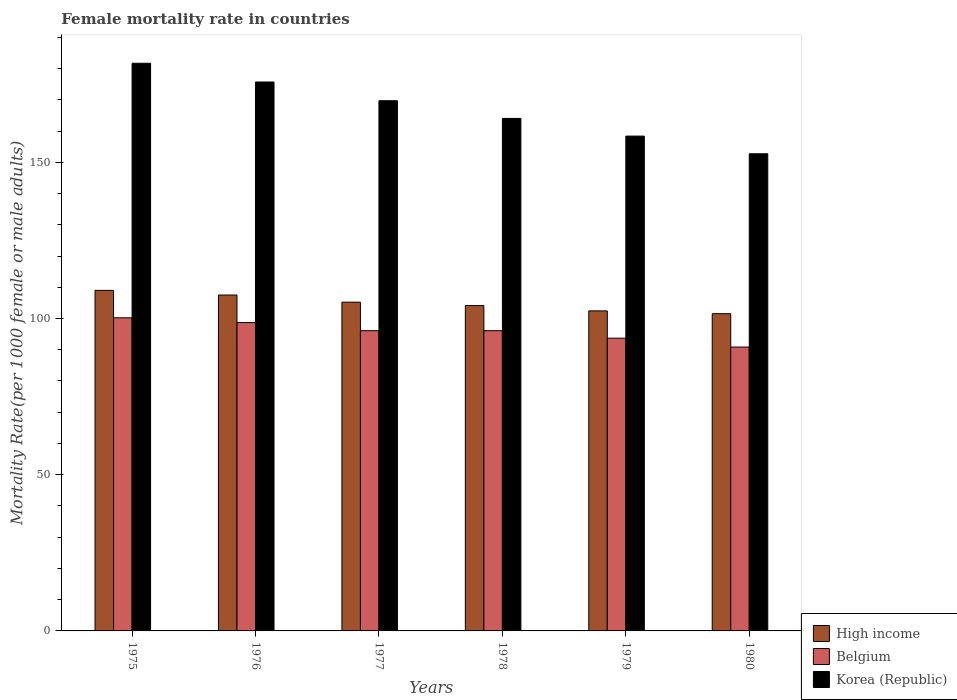Are the number of bars on each tick of the X-axis equal?
Your response must be concise. Yes. What is the label of the 4th group of bars from the left?
Make the answer very short. 1978. In how many cases, is the number of bars for a given year not equal to the number of legend labels?
Provide a succinct answer. 0. What is the female mortality rate in High income in 1977?
Your answer should be very brief. 105.23. Across all years, what is the maximum female mortality rate in Korea (Republic)?
Make the answer very short. 181.69. Across all years, what is the minimum female mortality rate in Korea (Republic)?
Ensure brevity in your answer.  152.72. In which year was the female mortality rate in Belgium maximum?
Provide a short and direct response. 1975. In which year was the female mortality rate in High income minimum?
Offer a very short reply. 1980. What is the total female mortality rate in High income in the graph?
Provide a succinct answer. 629.84. What is the difference between the female mortality rate in Belgium in 1976 and that in 1979?
Provide a short and direct response. 4.98. What is the difference between the female mortality rate in High income in 1976 and the female mortality rate in Belgium in 1979?
Your answer should be very brief. 13.81. What is the average female mortality rate in Korea (Republic) per year?
Make the answer very short. 167.04. In the year 1980, what is the difference between the female mortality rate in High income and female mortality rate in Korea (Republic)?
Ensure brevity in your answer.  -51.18. In how many years, is the female mortality rate in Belgium greater than 150?
Provide a succinct answer. 0. What is the ratio of the female mortality rate in Belgium in 1979 to that in 1980?
Your answer should be very brief. 1.03. Is the difference between the female mortality rate in High income in 1978 and 1980 greater than the difference between the female mortality rate in Korea (Republic) in 1978 and 1980?
Your answer should be compact. No. What is the difference between the highest and the second highest female mortality rate in Korea (Republic)?
Give a very brief answer. 6. What is the difference between the highest and the lowest female mortality rate in Korea (Republic)?
Your answer should be very brief. 28.97. In how many years, is the female mortality rate in High income greater than the average female mortality rate in High income taken over all years?
Your answer should be very brief. 3. Is the sum of the female mortality rate in Belgium in 1975 and 1977 greater than the maximum female mortality rate in Korea (Republic) across all years?
Provide a short and direct response. Yes. What does the 3rd bar from the left in 1978 represents?
Keep it short and to the point. Korea (Republic). Are all the bars in the graph horizontal?
Give a very brief answer. No. Are the values on the major ticks of Y-axis written in scientific E-notation?
Your answer should be very brief. No. How many legend labels are there?
Provide a short and direct response. 3. How are the legend labels stacked?
Offer a very short reply. Vertical. What is the title of the graph?
Offer a very short reply. Female mortality rate in countries. What is the label or title of the X-axis?
Offer a terse response. Years. What is the label or title of the Y-axis?
Provide a succinct answer. Mortality Rate(per 1000 female or male adults). What is the Mortality Rate(per 1000 female or male adults) in High income in 1975?
Provide a succinct answer. 109. What is the Mortality Rate(per 1000 female or male adults) in Belgium in 1975?
Your answer should be compact. 100.22. What is the Mortality Rate(per 1000 female or male adults) in Korea (Republic) in 1975?
Your response must be concise. 181.69. What is the Mortality Rate(per 1000 female or male adults) of High income in 1976?
Offer a very short reply. 107.51. What is the Mortality Rate(per 1000 female or male adults) in Belgium in 1976?
Your answer should be compact. 98.69. What is the Mortality Rate(per 1000 female or male adults) of Korea (Republic) in 1976?
Offer a very short reply. 175.7. What is the Mortality Rate(per 1000 female or male adults) of High income in 1977?
Offer a very short reply. 105.23. What is the Mortality Rate(per 1000 female or male adults) in Belgium in 1977?
Ensure brevity in your answer.  96.09. What is the Mortality Rate(per 1000 female or male adults) of Korea (Republic) in 1977?
Your answer should be compact. 169.7. What is the Mortality Rate(per 1000 female or male adults) in High income in 1978?
Provide a succinct answer. 104.13. What is the Mortality Rate(per 1000 female or male adults) in Belgium in 1978?
Ensure brevity in your answer.  96.09. What is the Mortality Rate(per 1000 female or male adults) of Korea (Republic) in 1978?
Give a very brief answer. 164.04. What is the Mortality Rate(per 1000 female or male adults) in High income in 1979?
Offer a very short reply. 102.43. What is the Mortality Rate(per 1000 female or male adults) in Belgium in 1979?
Provide a short and direct response. 93.7. What is the Mortality Rate(per 1000 female or male adults) in Korea (Republic) in 1979?
Offer a very short reply. 158.38. What is the Mortality Rate(per 1000 female or male adults) of High income in 1980?
Make the answer very short. 101.54. What is the Mortality Rate(per 1000 female or male adults) of Belgium in 1980?
Ensure brevity in your answer.  90.86. What is the Mortality Rate(per 1000 female or male adults) in Korea (Republic) in 1980?
Your answer should be compact. 152.72. Across all years, what is the maximum Mortality Rate(per 1000 female or male adults) of High income?
Offer a terse response. 109. Across all years, what is the maximum Mortality Rate(per 1000 female or male adults) of Belgium?
Give a very brief answer. 100.22. Across all years, what is the maximum Mortality Rate(per 1000 female or male adults) of Korea (Republic)?
Ensure brevity in your answer.  181.69. Across all years, what is the minimum Mortality Rate(per 1000 female or male adults) of High income?
Offer a terse response. 101.54. Across all years, what is the minimum Mortality Rate(per 1000 female or male adults) in Belgium?
Offer a very short reply. 90.86. Across all years, what is the minimum Mortality Rate(per 1000 female or male adults) in Korea (Republic)?
Give a very brief answer. 152.72. What is the total Mortality Rate(per 1000 female or male adults) of High income in the graph?
Offer a terse response. 629.84. What is the total Mortality Rate(per 1000 female or male adults) in Belgium in the graph?
Give a very brief answer. 575.66. What is the total Mortality Rate(per 1000 female or male adults) of Korea (Republic) in the graph?
Offer a very short reply. 1002.23. What is the difference between the Mortality Rate(per 1000 female or male adults) of High income in 1975 and that in 1976?
Your answer should be compact. 1.49. What is the difference between the Mortality Rate(per 1000 female or male adults) in Belgium in 1975 and that in 1976?
Your answer should be compact. 1.53. What is the difference between the Mortality Rate(per 1000 female or male adults) of Korea (Republic) in 1975 and that in 1976?
Give a very brief answer. 6. What is the difference between the Mortality Rate(per 1000 female or male adults) in High income in 1975 and that in 1977?
Provide a short and direct response. 3.77. What is the difference between the Mortality Rate(per 1000 female or male adults) in Belgium in 1975 and that in 1977?
Provide a succinct answer. 4.13. What is the difference between the Mortality Rate(per 1000 female or male adults) in Korea (Republic) in 1975 and that in 1977?
Your response must be concise. 11.99. What is the difference between the Mortality Rate(per 1000 female or male adults) in High income in 1975 and that in 1978?
Your answer should be compact. 4.87. What is the difference between the Mortality Rate(per 1000 female or male adults) in Belgium in 1975 and that in 1978?
Offer a terse response. 4.13. What is the difference between the Mortality Rate(per 1000 female or male adults) of Korea (Republic) in 1975 and that in 1978?
Keep it short and to the point. 17.65. What is the difference between the Mortality Rate(per 1000 female or male adults) of High income in 1975 and that in 1979?
Give a very brief answer. 6.56. What is the difference between the Mortality Rate(per 1000 female or male adults) in Belgium in 1975 and that in 1979?
Ensure brevity in your answer.  6.52. What is the difference between the Mortality Rate(per 1000 female or male adults) in Korea (Republic) in 1975 and that in 1979?
Keep it short and to the point. 23.31. What is the difference between the Mortality Rate(per 1000 female or male adults) of High income in 1975 and that in 1980?
Give a very brief answer. 7.46. What is the difference between the Mortality Rate(per 1000 female or male adults) in Belgium in 1975 and that in 1980?
Ensure brevity in your answer.  9.36. What is the difference between the Mortality Rate(per 1000 female or male adults) in Korea (Republic) in 1975 and that in 1980?
Offer a terse response. 28.97. What is the difference between the Mortality Rate(per 1000 female or male adults) of High income in 1976 and that in 1977?
Keep it short and to the point. 2.28. What is the difference between the Mortality Rate(per 1000 female or male adults) of Belgium in 1976 and that in 1977?
Provide a short and direct response. 2.6. What is the difference between the Mortality Rate(per 1000 female or male adults) of Korea (Republic) in 1976 and that in 1977?
Offer a very short reply. 6. What is the difference between the Mortality Rate(per 1000 female or male adults) in High income in 1976 and that in 1978?
Provide a short and direct response. 3.38. What is the difference between the Mortality Rate(per 1000 female or male adults) in Belgium in 1976 and that in 1978?
Provide a short and direct response. 2.59. What is the difference between the Mortality Rate(per 1000 female or male adults) in Korea (Republic) in 1976 and that in 1978?
Keep it short and to the point. 11.66. What is the difference between the Mortality Rate(per 1000 female or male adults) in High income in 1976 and that in 1979?
Give a very brief answer. 5.08. What is the difference between the Mortality Rate(per 1000 female or male adults) of Belgium in 1976 and that in 1979?
Ensure brevity in your answer.  4.98. What is the difference between the Mortality Rate(per 1000 female or male adults) in Korea (Republic) in 1976 and that in 1979?
Your answer should be compact. 17.32. What is the difference between the Mortality Rate(per 1000 female or male adults) of High income in 1976 and that in 1980?
Your answer should be very brief. 5.97. What is the difference between the Mortality Rate(per 1000 female or male adults) of Belgium in 1976 and that in 1980?
Provide a succinct answer. 7.83. What is the difference between the Mortality Rate(per 1000 female or male adults) of Korea (Republic) in 1976 and that in 1980?
Provide a short and direct response. 22.98. What is the difference between the Mortality Rate(per 1000 female or male adults) of High income in 1977 and that in 1978?
Give a very brief answer. 1.1. What is the difference between the Mortality Rate(per 1000 female or male adults) of Belgium in 1977 and that in 1978?
Your answer should be compact. -0. What is the difference between the Mortality Rate(per 1000 female or male adults) in Korea (Republic) in 1977 and that in 1978?
Keep it short and to the point. 5.66. What is the difference between the Mortality Rate(per 1000 female or male adults) of High income in 1977 and that in 1979?
Your response must be concise. 2.79. What is the difference between the Mortality Rate(per 1000 female or male adults) of Belgium in 1977 and that in 1979?
Give a very brief answer. 2.39. What is the difference between the Mortality Rate(per 1000 female or male adults) in Korea (Republic) in 1977 and that in 1979?
Provide a succinct answer. 11.32. What is the difference between the Mortality Rate(per 1000 female or male adults) of High income in 1977 and that in 1980?
Provide a succinct answer. 3.69. What is the difference between the Mortality Rate(per 1000 female or male adults) of Belgium in 1977 and that in 1980?
Your answer should be compact. 5.23. What is the difference between the Mortality Rate(per 1000 female or male adults) of Korea (Republic) in 1977 and that in 1980?
Provide a succinct answer. 16.98. What is the difference between the Mortality Rate(per 1000 female or male adults) in High income in 1978 and that in 1979?
Ensure brevity in your answer.  1.7. What is the difference between the Mortality Rate(per 1000 female or male adults) of Belgium in 1978 and that in 1979?
Keep it short and to the point. 2.39. What is the difference between the Mortality Rate(per 1000 female or male adults) of Korea (Republic) in 1978 and that in 1979?
Your answer should be very brief. 5.66. What is the difference between the Mortality Rate(per 1000 female or male adults) of High income in 1978 and that in 1980?
Make the answer very short. 2.59. What is the difference between the Mortality Rate(per 1000 female or male adults) of Belgium in 1978 and that in 1980?
Your answer should be very brief. 5.24. What is the difference between the Mortality Rate(per 1000 female or male adults) in Korea (Republic) in 1978 and that in 1980?
Ensure brevity in your answer.  11.32. What is the difference between the Mortality Rate(per 1000 female or male adults) of High income in 1979 and that in 1980?
Provide a succinct answer. 0.89. What is the difference between the Mortality Rate(per 1000 female or male adults) of Belgium in 1979 and that in 1980?
Offer a very short reply. 2.85. What is the difference between the Mortality Rate(per 1000 female or male adults) in Korea (Republic) in 1979 and that in 1980?
Keep it short and to the point. 5.66. What is the difference between the Mortality Rate(per 1000 female or male adults) in High income in 1975 and the Mortality Rate(per 1000 female or male adults) in Belgium in 1976?
Provide a short and direct response. 10.31. What is the difference between the Mortality Rate(per 1000 female or male adults) in High income in 1975 and the Mortality Rate(per 1000 female or male adults) in Korea (Republic) in 1976?
Make the answer very short. -66.7. What is the difference between the Mortality Rate(per 1000 female or male adults) in Belgium in 1975 and the Mortality Rate(per 1000 female or male adults) in Korea (Republic) in 1976?
Give a very brief answer. -75.48. What is the difference between the Mortality Rate(per 1000 female or male adults) of High income in 1975 and the Mortality Rate(per 1000 female or male adults) of Belgium in 1977?
Keep it short and to the point. 12.9. What is the difference between the Mortality Rate(per 1000 female or male adults) in High income in 1975 and the Mortality Rate(per 1000 female or male adults) in Korea (Republic) in 1977?
Your answer should be very brief. -60.7. What is the difference between the Mortality Rate(per 1000 female or male adults) of Belgium in 1975 and the Mortality Rate(per 1000 female or male adults) of Korea (Republic) in 1977?
Provide a short and direct response. -69.48. What is the difference between the Mortality Rate(per 1000 female or male adults) of High income in 1975 and the Mortality Rate(per 1000 female or male adults) of Belgium in 1978?
Keep it short and to the point. 12.9. What is the difference between the Mortality Rate(per 1000 female or male adults) in High income in 1975 and the Mortality Rate(per 1000 female or male adults) in Korea (Republic) in 1978?
Keep it short and to the point. -55.04. What is the difference between the Mortality Rate(per 1000 female or male adults) of Belgium in 1975 and the Mortality Rate(per 1000 female or male adults) of Korea (Republic) in 1978?
Your answer should be compact. -63.82. What is the difference between the Mortality Rate(per 1000 female or male adults) in High income in 1975 and the Mortality Rate(per 1000 female or male adults) in Belgium in 1979?
Make the answer very short. 15.29. What is the difference between the Mortality Rate(per 1000 female or male adults) of High income in 1975 and the Mortality Rate(per 1000 female or male adults) of Korea (Republic) in 1979?
Offer a very short reply. -49.38. What is the difference between the Mortality Rate(per 1000 female or male adults) in Belgium in 1975 and the Mortality Rate(per 1000 female or male adults) in Korea (Republic) in 1979?
Your answer should be very brief. -58.16. What is the difference between the Mortality Rate(per 1000 female or male adults) in High income in 1975 and the Mortality Rate(per 1000 female or male adults) in Belgium in 1980?
Your response must be concise. 18.14. What is the difference between the Mortality Rate(per 1000 female or male adults) of High income in 1975 and the Mortality Rate(per 1000 female or male adults) of Korea (Republic) in 1980?
Make the answer very short. -43.72. What is the difference between the Mortality Rate(per 1000 female or male adults) in Belgium in 1975 and the Mortality Rate(per 1000 female or male adults) in Korea (Republic) in 1980?
Make the answer very short. -52.5. What is the difference between the Mortality Rate(per 1000 female or male adults) in High income in 1976 and the Mortality Rate(per 1000 female or male adults) in Belgium in 1977?
Give a very brief answer. 11.42. What is the difference between the Mortality Rate(per 1000 female or male adults) in High income in 1976 and the Mortality Rate(per 1000 female or male adults) in Korea (Republic) in 1977?
Your answer should be very brief. -62.19. What is the difference between the Mortality Rate(per 1000 female or male adults) of Belgium in 1976 and the Mortality Rate(per 1000 female or male adults) of Korea (Republic) in 1977?
Offer a terse response. -71.01. What is the difference between the Mortality Rate(per 1000 female or male adults) of High income in 1976 and the Mortality Rate(per 1000 female or male adults) of Belgium in 1978?
Provide a succinct answer. 11.42. What is the difference between the Mortality Rate(per 1000 female or male adults) in High income in 1976 and the Mortality Rate(per 1000 female or male adults) in Korea (Republic) in 1978?
Your response must be concise. -56.53. What is the difference between the Mortality Rate(per 1000 female or male adults) of Belgium in 1976 and the Mortality Rate(per 1000 female or male adults) of Korea (Republic) in 1978?
Your answer should be compact. -65.35. What is the difference between the Mortality Rate(per 1000 female or male adults) of High income in 1976 and the Mortality Rate(per 1000 female or male adults) of Belgium in 1979?
Ensure brevity in your answer.  13.81. What is the difference between the Mortality Rate(per 1000 female or male adults) of High income in 1976 and the Mortality Rate(per 1000 female or male adults) of Korea (Republic) in 1979?
Provide a succinct answer. -50.87. What is the difference between the Mortality Rate(per 1000 female or male adults) of Belgium in 1976 and the Mortality Rate(per 1000 female or male adults) of Korea (Republic) in 1979?
Keep it short and to the point. -59.69. What is the difference between the Mortality Rate(per 1000 female or male adults) of High income in 1976 and the Mortality Rate(per 1000 female or male adults) of Belgium in 1980?
Provide a succinct answer. 16.65. What is the difference between the Mortality Rate(per 1000 female or male adults) of High income in 1976 and the Mortality Rate(per 1000 female or male adults) of Korea (Republic) in 1980?
Offer a very short reply. -45.21. What is the difference between the Mortality Rate(per 1000 female or male adults) in Belgium in 1976 and the Mortality Rate(per 1000 female or male adults) in Korea (Republic) in 1980?
Offer a very short reply. -54.03. What is the difference between the Mortality Rate(per 1000 female or male adults) of High income in 1977 and the Mortality Rate(per 1000 female or male adults) of Belgium in 1978?
Make the answer very short. 9.13. What is the difference between the Mortality Rate(per 1000 female or male adults) of High income in 1977 and the Mortality Rate(per 1000 female or male adults) of Korea (Republic) in 1978?
Offer a terse response. -58.81. What is the difference between the Mortality Rate(per 1000 female or male adults) of Belgium in 1977 and the Mortality Rate(per 1000 female or male adults) of Korea (Republic) in 1978?
Offer a very short reply. -67.95. What is the difference between the Mortality Rate(per 1000 female or male adults) in High income in 1977 and the Mortality Rate(per 1000 female or male adults) in Belgium in 1979?
Your answer should be very brief. 11.52. What is the difference between the Mortality Rate(per 1000 female or male adults) in High income in 1977 and the Mortality Rate(per 1000 female or male adults) in Korea (Republic) in 1979?
Ensure brevity in your answer.  -53.15. What is the difference between the Mortality Rate(per 1000 female or male adults) in Belgium in 1977 and the Mortality Rate(per 1000 female or male adults) in Korea (Republic) in 1979?
Provide a short and direct response. -62.29. What is the difference between the Mortality Rate(per 1000 female or male adults) of High income in 1977 and the Mortality Rate(per 1000 female or male adults) of Belgium in 1980?
Provide a short and direct response. 14.37. What is the difference between the Mortality Rate(per 1000 female or male adults) in High income in 1977 and the Mortality Rate(per 1000 female or male adults) in Korea (Republic) in 1980?
Ensure brevity in your answer.  -47.49. What is the difference between the Mortality Rate(per 1000 female or male adults) in Belgium in 1977 and the Mortality Rate(per 1000 female or male adults) in Korea (Republic) in 1980?
Offer a very short reply. -56.63. What is the difference between the Mortality Rate(per 1000 female or male adults) in High income in 1978 and the Mortality Rate(per 1000 female or male adults) in Belgium in 1979?
Offer a very short reply. 10.43. What is the difference between the Mortality Rate(per 1000 female or male adults) in High income in 1978 and the Mortality Rate(per 1000 female or male adults) in Korea (Republic) in 1979?
Your answer should be compact. -54.25. What is the difference between the Mortality Rate(per 1000 female or male adults) in Belgium in 1978 and the Mortality Rate(per 1000 female or male adults) in Korea (Republic) in 1979?
Make the answer very short. -62.29. What is the difference between the Mortality Rate(per 1000 female or male adults) in High income in 1978 and the Mortality Rate(per 1000 female or male adults) in Belgium in 1980?
Make the answer very short. 13.27. What is the difference between the Mortality Rate(per 1000 female or male adults) in High income in 1978 and the Mortality Rate(per 1000 female or male adults) in Korea (Republic) in 1980?
Offer a very short reply. -48.59. What is the difference between the Mortality Rate(per 1000 female or male adults) of Belgium in 1978 and the Mortality Rate(per 1000 female or male adults) of Korea (Republic) in 1980?
Your response must be concise. -56.63. What is the difference between the Mortality Rate(per 1000 female or male adults) in High income in 1979 and the Mortality Rate(per 1000 female or male adults) in Belgium in 1980?
Offer a very short reply. 11.58. What is the difference between the Mortality Rate(per 1000 female or male adults) of High income in 1979 and the Mortality Rate(per 1000 female or male adults) of Korea (Republic) in 1980?
Keep it short and to the point. -50.29. What is the difference between the Mortality Rate(per 1000 female or male adults) of Belgium in 1979 and the Mortality Rate(per 1000 female or male adults) of Korea (Republic) in 1980?
Your answer should be very brief. -59.02. What is the average Mortality Rate(per 1000 female or male adults) of High income per year?
Offer a terse response. 104.97. What is the average Mortality Rate(per 1000 female or male adults) in Belgium per year?
Provide a short and direct response. 95.94. What is the average Mortality Rate(per 1000 female or male adults) of Korea (Republic) per year?
Your answer should be compact. 167.04. In the year 1975, what is the difference between the Mortality Rate(per 1000 female or male adults) in High income and Mortality Rate(per 1000 female or male adults) in Belgium?
Provide a short and direct response. 8.77. In the year 1975, what is the difference between the Mortality Rate(per 1000 female or male adults) in High income and Mortality Rate(per 1000 female or male adults) in Korea (Republic)?
Offer a very short reply. -72.7. In the year 1975, what is the difference between the Mortality Rate(per 1000 female or male adults) of Belgium and Mortality Rate(per 1000 female or male adults) of Korea (Republic)?
Make the answer very short. -81.47. In the year 1976, what is the difference between the Mortality Rate(per 1000 female or male adults) of High income and Mortality Rate(per 1000 female or male adults) of Belgium?
Ensure brevity in your answer.  8.82. In the year 1976, what is the difference between the Mortality Rate(per 1000 female or male adults) in High income and Mortality Rate(per 1000 female or male adults) in Korea (Republic)?
Give a very brief answer. -68.19. In the year 1976, what is the difference between the Mortality Rate(per 1000 female or male adults) in Belgium and Mortality Rate(per 1000 female or male adults) in Korea (Republic)?
Give a very brief answer. -77.01. In the year 1977, what is the difference between the Mortality Rate(per 1000 female or male adults) in High income and Mortality Rate(per 1000 female or male adults) in Belgium?
Offer a terse response. 9.13. In the year 1977, what is the difference between the Mortality Rate(per 1000 female or male adults) of High income and Mortality Rate(per 1000 female or male adults) of Korea (Republic)?
Your answer should be very brief. -64.47. In the year 1977, what is the difference between the Mortality Rate(per 1000 female or male adults) of Belgium and Mortality Rate(per 1000 female or male adults) of Korea (Republic)?
Your response must be concise. -73.61. In the year 1978, what is the difference between the Mortality Rate(per 1000 female or male adults) of High income and Mortality Rate(per 1000 female or male adults) of Belgium?
Give a very brief answer. 8.04. In the year 1978, what is the difference between the Mortality Rate(per 1000 female or male adults) of High income and Mortality Rate(per 1000 female or male adults) of Korea (Republic)?
Your answer should be compact. -59.91. In the year 1978, what is the difference between the Mortality Rate(per 1000 female or male adults) in Belgium and Mortality Rate(per 1000 female or male adults) in Korea (Republic)?
Your answer should be compact. -67.95. In the year 1979, what is the difference between the Mortality Rate(per 1000 female or male adults) of High income and Mortality Rate(per 1000 female or male adults) of Belgium?
Offer a terse response. 8.73. In the year 1979, what is the difference between the Mortality Rate(per 1000 female or male adults) of High income and Mortality Rate(per 1000 female or male adults) of Korea (Republic)?
Your answer should be very brief. -55.95. In the year 1979, what is the difference between the Mortality Rate(per 1000 female or male adults) in Belgium and Mortality Rate(per 1000 female or male adults) in Korea (Republic)?
Make the answer very short. -64.68. In the year 1980, what is the difference between the Mortality Rate(per 1000 female or male adults) in High income and Mortality Rate(per 1000 female or male adults) in Belgium?
Provide a succinct answer. 10.68. In the year 1980, what is the difference between the Mortality Rate(per 1000 female or male adults) of High income and Mortality Rate(per 1000 female or male adults) of Korea (Republic)?
Ensure brevity in your answer.  -51.18. In the year 1980, what is the difference between the Mortality Rate(per 1000 female or male adults) of Belgium and Mortality Rate(per 1000 female or male adults) of Korea (Republic)?
Provide a short and direct response. -61.86. What is the ratio of the Mortality Rate(per 1000 female or male adults) in High income in 1975 to that in 1976?
Your answer should be compact. 1.01. What is the ratio of the Mortality Rate(per 1000 female or male adults) of Belgium in 1975 to that in 1976?
Keep it short and to the point. 1.02. What is the ratio of the Mortality Rate(per 1000 female or male adults) of Korea (Republic) in 1975 to that in 1976?
Give a very brief answer. 1.03. What is the ratio of the Mortality Rate(per 1000 female or male adults) in High income in 1975 to that in 1977?
Offer a terse response. 1.04. What is the ratio of the Mortality Rate(per 1000 female or male adults) of Belgium in 1975 to that in 1977?
Make the answer very short. 1.04. What is the ratio of the Mortality Rate(per 1000 female or male adults) in Korea (Republic) in 1975 to that in 1977?
Provide a short and direct response. 1.07. What is the ratio of the Mortality Rate(per 1000 female or male adults) in High income in 1975 to that in 1978?
Offer a terse response. 1.05. What is the ratio of the Mortality Rate(per 1000 female or male adults) in Belgium in 1975 to that in 1978?
Offer a terse response. 1.04. What is the ratio of the Mortality Rate(per 1000 female or male adults) of Korea (Republic) in 1975 to that in 1978?
Your response must be concise. 1.11. What is the ratio of the Mortality Rate(per 1000 female or male adults) of High income in 1975 to that in 1979?
Your response must be concise. 1.06. What is the ratio of the Mortality Rate(per 1000 female or male adults) in Belgium in 1975 to that in 1979?
Ensure brevity in your answer.  1.07. What is the ratio of the Mortality Rate(per 1000 female or male adults) in Korea (Republic) in 1975 to that in 1979?
Your answer should be compact. 1.15. What is the ratio of the Mortality Rate(per 1000 female or male adults) of High income in 1975 to that in 1980?
Ensure brevity in your answer.  1.07. What is the ratio of the Mortality Rate(per 1000 female or male adults) of Belgium in 1975 to that in 1980?
Make the answer very short. 1.1. What is the ratio of the Mortality Rate(per 1000 female or male adults) of Korea (Republic) in 1975 to that in 1980?
Provide a succinct answer. 1.19. What is the ratio of the Mortality Rate(per 1000 female or male adults) of High income in 1976 to that in 1977?
Offer a terse response. 1.02. What is the ratio of the Mortality Rate(per 1000 female or male adults) in Korea (Republic) in 1976 to that in 1977?
Your response must be concise. 1.04. What is the ratio of the Mortality Rate(per 1000 female or male adults) of High income in 1976 to that in 1978?
Your answer should be compact. 1.03. What is the ratio of the Mortality Rate(per 1000 female or male adults) of Belgium in 1976 to that in 1978?
Make the answer very short. 1.03. What is the ratio of the Mortality Rate(per 1000 female or male adults) in Korea (Republic) in 1976 to that in 1978?
Offer a terse response. 1.07. What is the ratio of the Mortality Rate(per 1000 female or male adults) of High income in 1976 to that in 1979?
Your response must be concise. 1.05. What is the ratio of the Mortality Rate(per 1000 female or male adults) of Belgium in 1976 to that in 1979?
Your answer should be very brief. 1.05. What is the ratio of the Mortality Rate(per 1000 female or male adults) in Korea (Republic) in 1976 to that in 1979?
Provide a short and direct response. 1.11. What is the ratio of the Mortality Rate(per 1000 female or male adults) in High income in 1976 to that in 1980?
Offer a very short reply. 1.06. What is the ratio of the Mortality Rate(per 1000 female or male adults) in Belgium in 1976 to that in 1980?
Your response must be concise. 1.09. What is the ratio of the Mortality Rate(per 1000 female or male adults) of Korea (Republic) in 1976 to that in 1980?
Make the answer very short. 1.15. What is the ratio of the Mortality Rate(per 1000 female or male adults) of High income in 1977 to that in 1978?
Provide a succinct answer. 1.01. What is the ratio of the Mortality Rate(per 1000 female or male adults) of Korea (Republic) in 1977 to that in 1978?
Your response must be concise. 1.03. What is the ratio of the Mortality Rate(per 1000 female or male adults) in High income in 1977 to that in 1979?
Give a very brief answer. 1.03. What is the ratio of the Mortality Rate(per 1000 female or male adults) in Belgium in 1977 to that in 1979?
Your answer should be very brief. 1.03. What is the ratio of the Mortality Rate(per 1000 female or male adults) of Korea (Republic) in 1977 to that in 1979?
Keep it short and to the point. 1.07. What is the ratio of the Mortality Rate(per 1000 female or male adults) of High income in 1977 to that in 1980?
Make the answer very short. 1.04. What is the ratio of the Mortality Rate(per 1000 female or male adults) in Belgium in 1977 to that in 1980?
Provide a short and direct response. 1.06. What is the ratio of the Mortality Rate(per 1000 female or male adults) of Korea (Republic) in 1977 to that in 1980?
Keep it short and to the point. 1.11. What is the ratio of the Mortality Rate(per 1000 female or male adults) in High income in 1978 to that in 1979?
Your answer should be very brief. 1.02. What is the ratio of the Mortality Rate(per 1000 female or male adults) in Belgium in 1978 to that in 1979?
Your response must be concise. 1.03. What is the ratio of the Mortality Rate(per 1000 female or male adults) of Korea (Republic) in 1978 to that in 1979?
Your response must be concise. 1.04. What is the ratio of the Mortality Rate(per 1000 female or male adults) of High income in 1978 to that in 1980?
Offer a very short reply. 1.03. What is the ratio of the Mortality Rate(per 1000 female or male adults) in Belgium in 1978 to that in 1980?
Offer a very short reply. 1.06. What is the ratio of the Mortality Rate(per 1000 female or male adults) of Korea (Republic) in 1978 to that in 1980?
Keep it short and to the point. 1.07. What is the ratio of the Mortality Rate(per 1000 female or male adults) of High income in 1979 to that in 1980?
Keep it short and to the point. 1.01. What is the ratio of the Mortality Rate(per 1000 female or male adults) of Belgium in 1979 to that in 1980?
Make the answer very short. 1.03. What is the ratio of the Mortality Rate(per 1000 female or male adults) in Korea (Republic) in 1979 to that in 1980?
Offer a terse response. 1.04. What is the difference between the highest and the second highest Mortality Rate(per 1000 female or male adults) of High income?
Your answer should be compact. 1.49. What is the difference between the highest and the second highest Mortality Rate(per 1000 female or male adults) in Belgium?
Your answer should be very brief. 1.53. What is the difference between the highest and the second highest Mortality Rate(per 1000 female or male adults) in Korea (Republic)?
Your answer should be compact. 6. What is the difference between the highest and the lowest Mortality Rate(per 1000 female or male adults) in High income?
Ensure brevity in your answer.  7.46. What is the difference between the highest and the lowest Mortality Rate(per 1000 female or male adults) of Belgium?
Provide a short and direct response. 9.36. What is the difference between the highest and the lowest Mortality Rate(per 1000 female or male adults) of Korea (Republic)?
Your answer should be very brief. 28.97. 